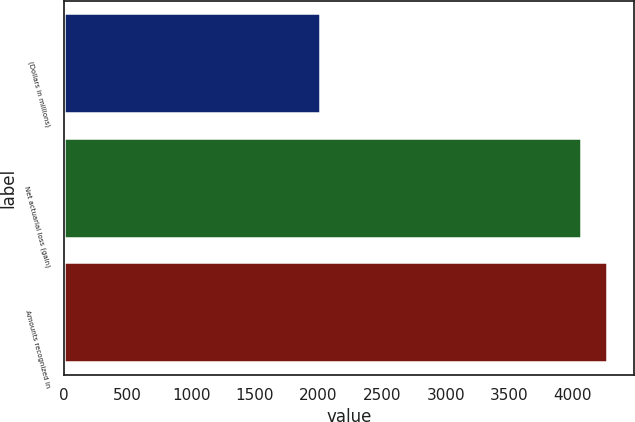Convert chart to OTSL. <chart><loc_0><loc_0><loc_500><loc_500><bar_chart><fcel>(Dollars in millions)<fcel>Net actuarial loss (gain)<fcel>Amounts recognized in<nl><fcel>2014<fcel>4061<fcel>4265.7<nl></chart> 